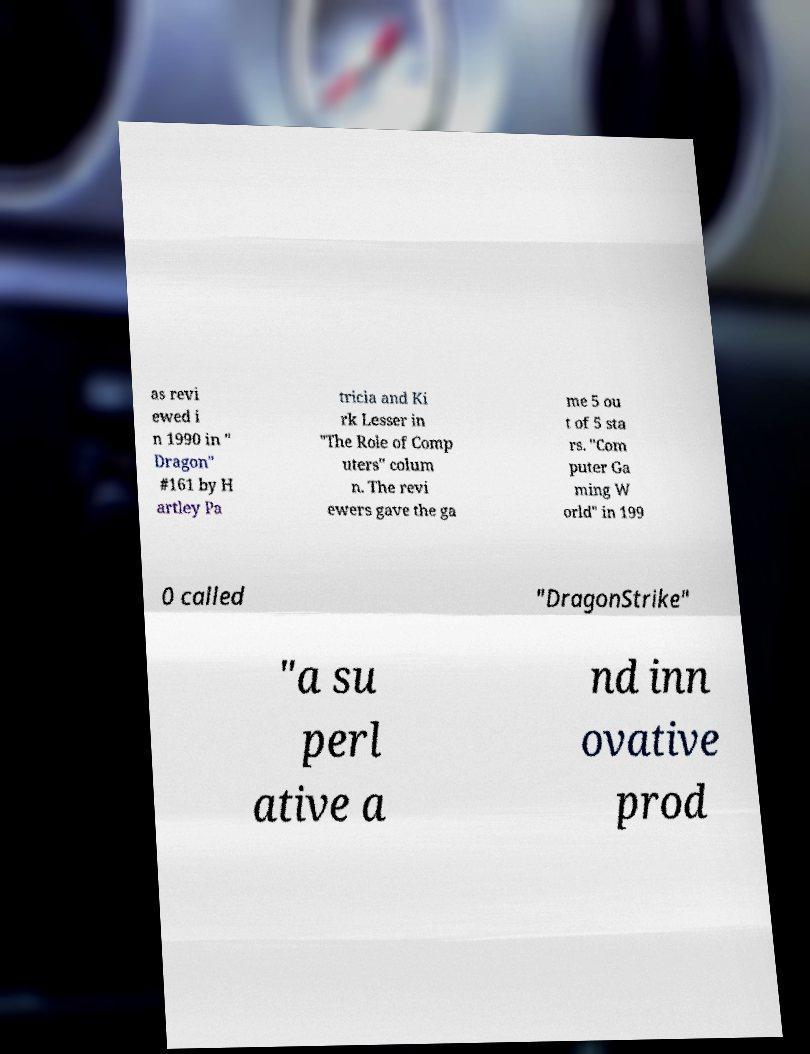Could you assist in decoding the text presented in this image and type it out clearly? as revi ewed i n 1990 in " Dragon" #161 by H artley Pa tricia and Ki rk Lesser in "The Role of Comp uters" colum n. The revi ewers gave the ga me 5 ou t of 5 sta rs. "Com puter Ga ming W orld" in 199 0 called "DragonStrike" "a su perl ative a nd inn ovative prod 